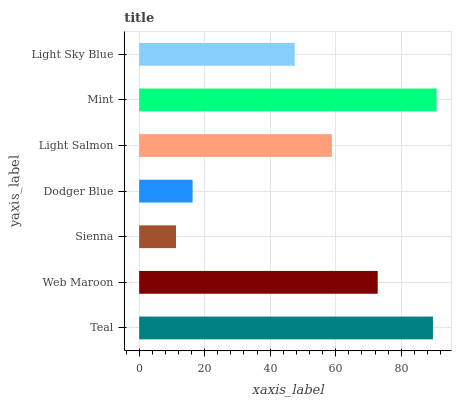Is Sienna the minimum?
Answer yes or no. Yes. Is Mint the maximum?
Answer yes or no. Yes. Is Web Maroon the minimum?
Answer yes or no. No. Is Web Maroon the maximum?
Answer yes or no. No. Is Teal greater than Web Maroon?
Answer yes or no. Yes. Is Web Maroon less than Teal?
Answer yes or no. Yes. Is Web Maroon greater than Teal?
Answer yes or no. No. Is Teal less than Web Maroon?
Answer yes or no. No. Is Light Salmon the high median?
Answer yes or no. Yes. Is Light Salmon the low median?
Answer yes or no. Yes. Is Light Sky Blue the high median?
Answer yes or no. No. Is Teal the low median?
Answer yes or no. No. 